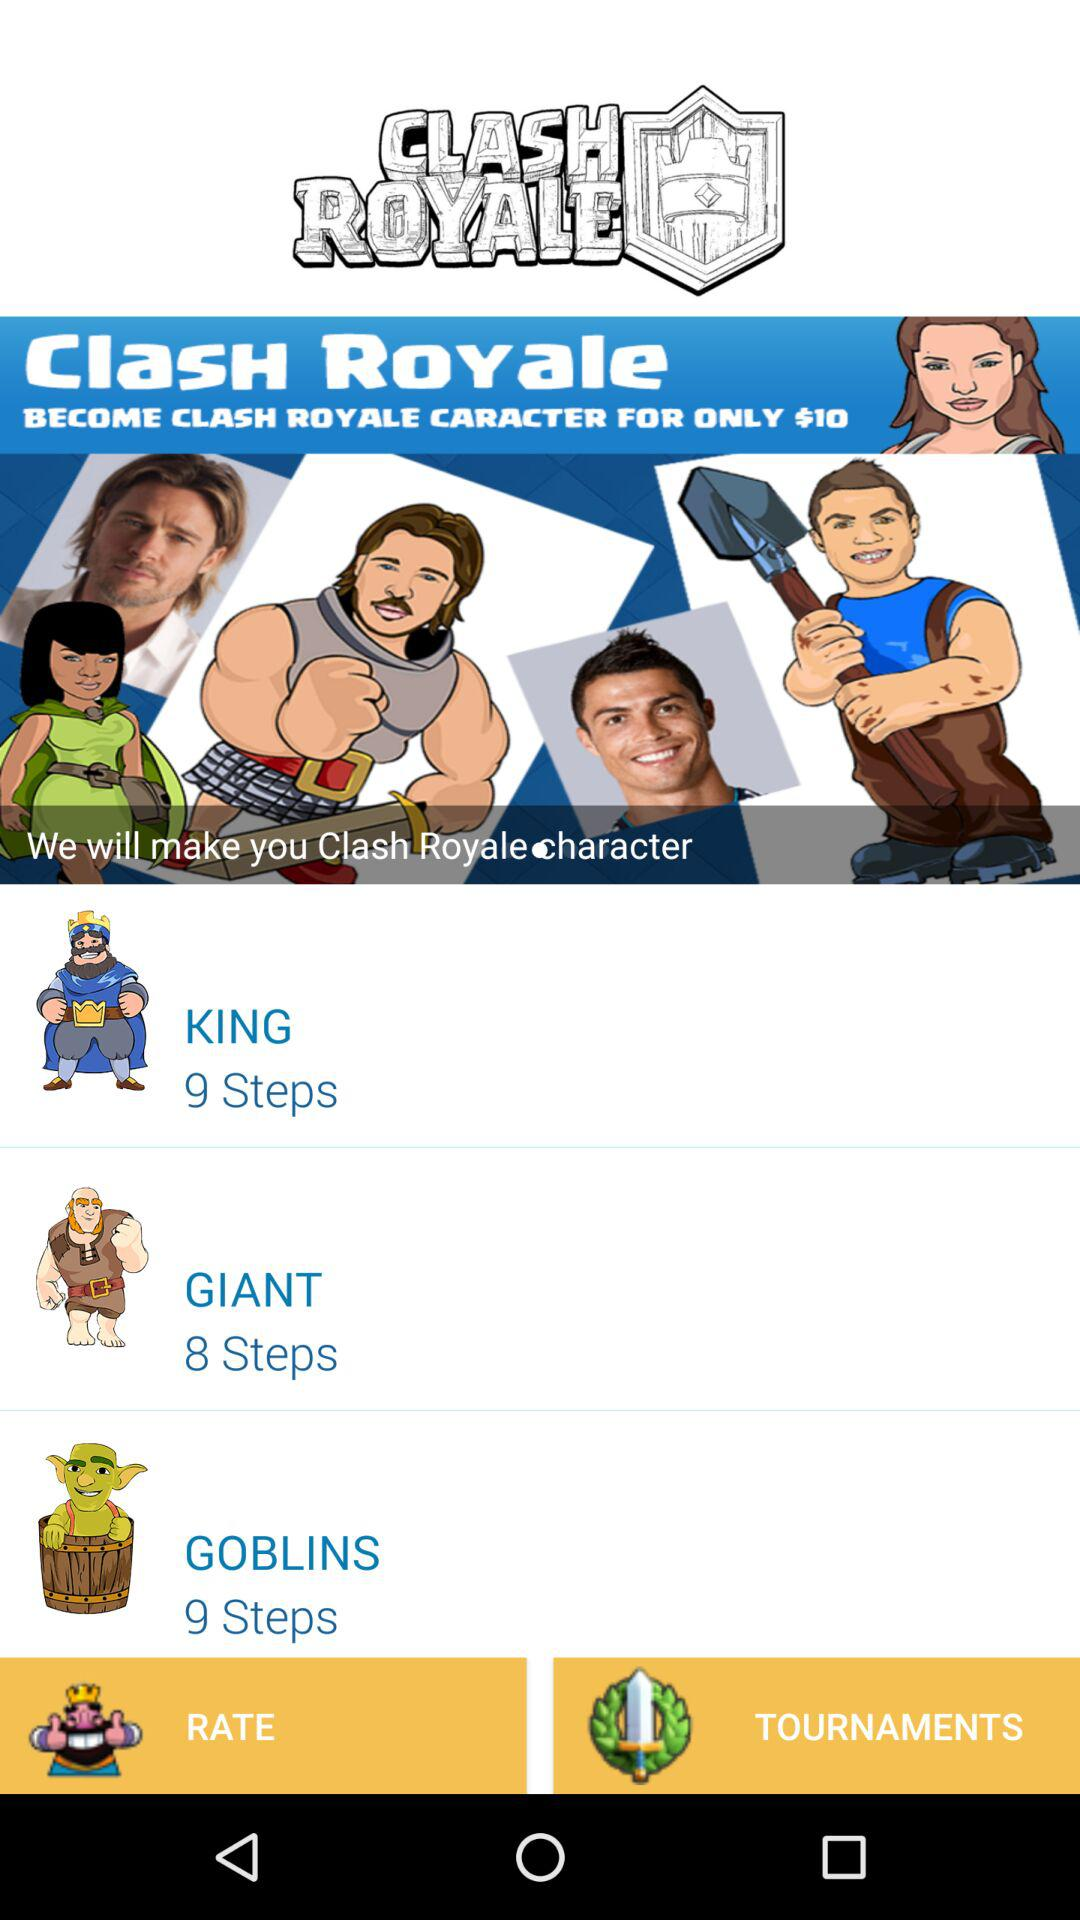What is the count of steps for "KING"? The count of steps for "KING" is 9. 